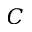<formula> <loc_0><loc_0><loc_500><loc_500>C</formula> 